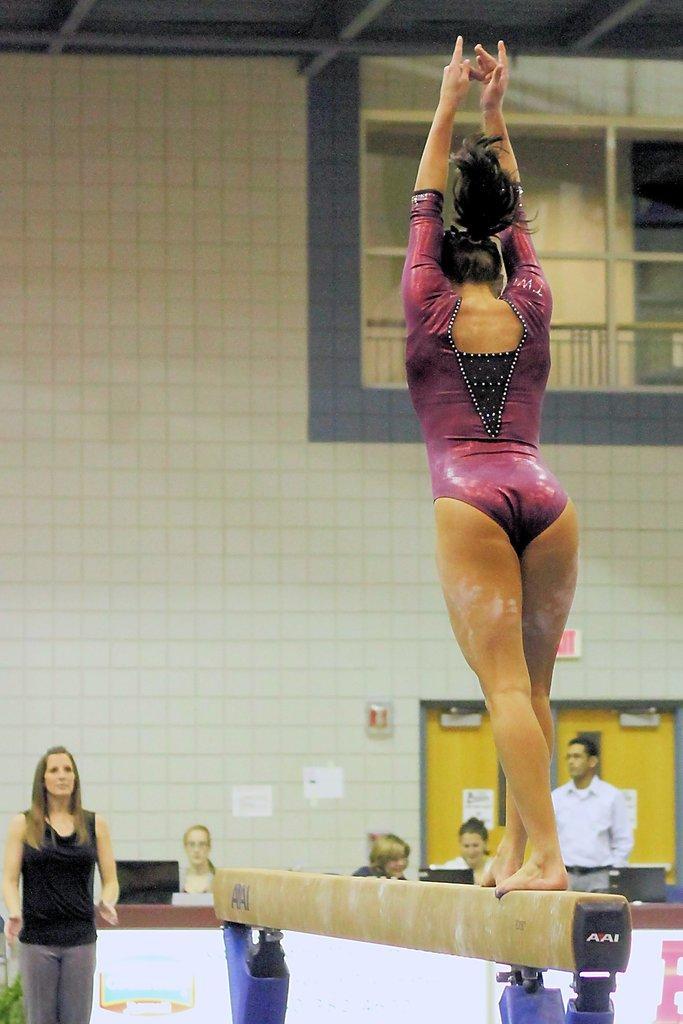In one or two sentences, can you explain what this image depicts? On the right side of the image we can see lady standing on the balance beam. In the background there are people and we can see laptops placed on the table and we can see a wall. At the top there is a window. 